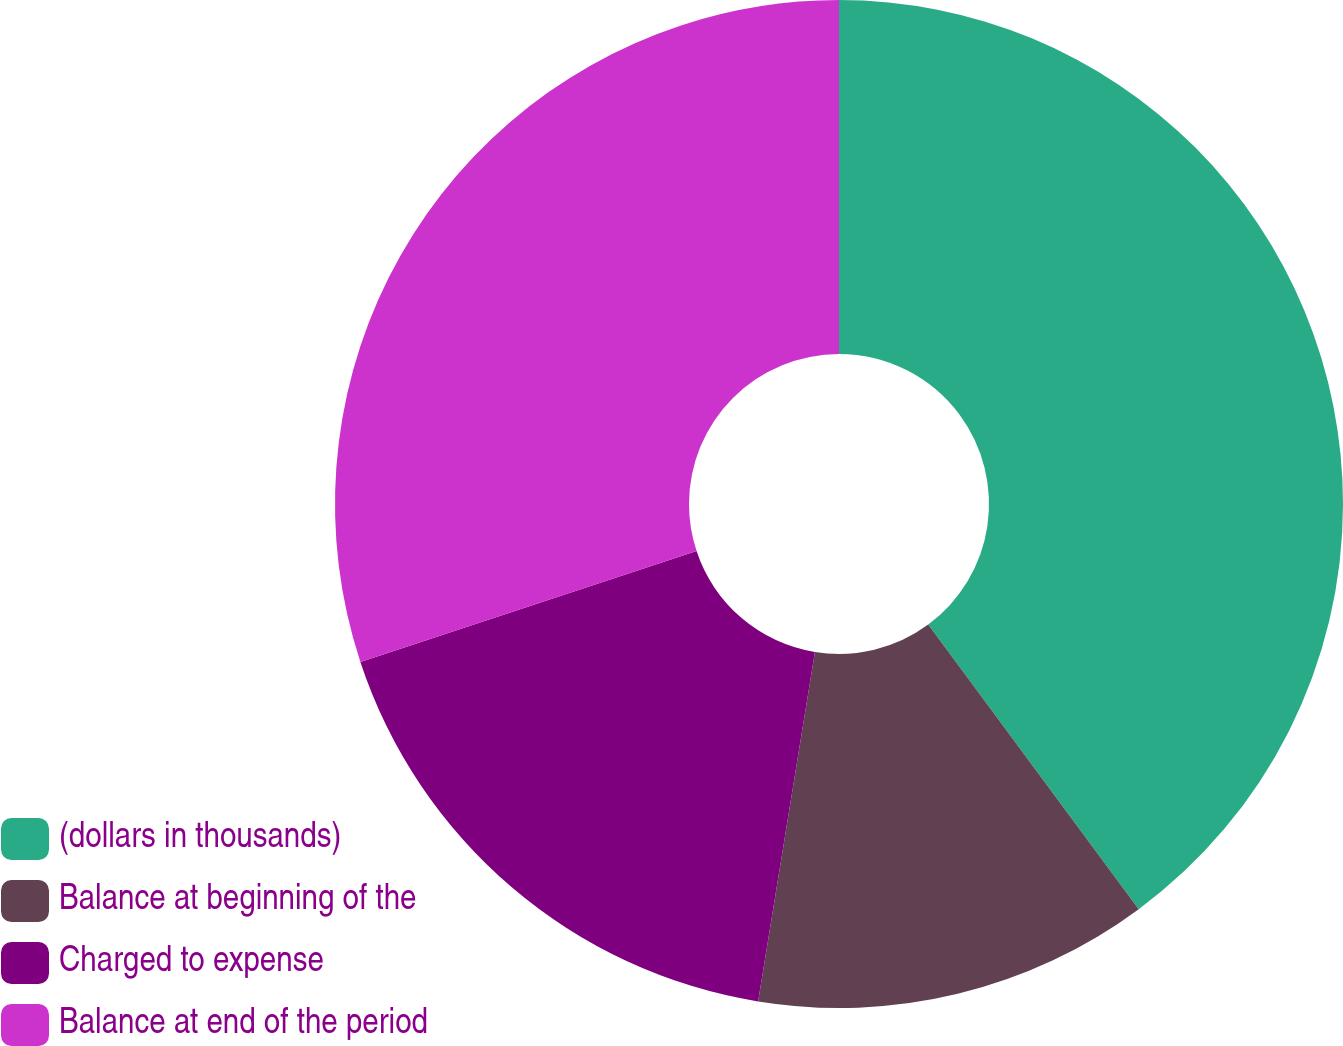Convert chart to OTSL. <chart><loc_0><loc_0><loc_500><loc_500><pie_chart><fcel>(dollars in thousands)<fcel>Balance at beginning of the<fcel>Charged to expense<fcel>Balance at end of the period<nl><fcel>39.86%<fcel>12.7%<fcel>17.36%<fcel>30.07%<nl></chart> 